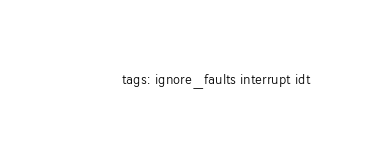<code> <loc_0><loc_0><loc_500><loc_500><_YAML_>    tags: ignore_faults interrupt idt
</code> 